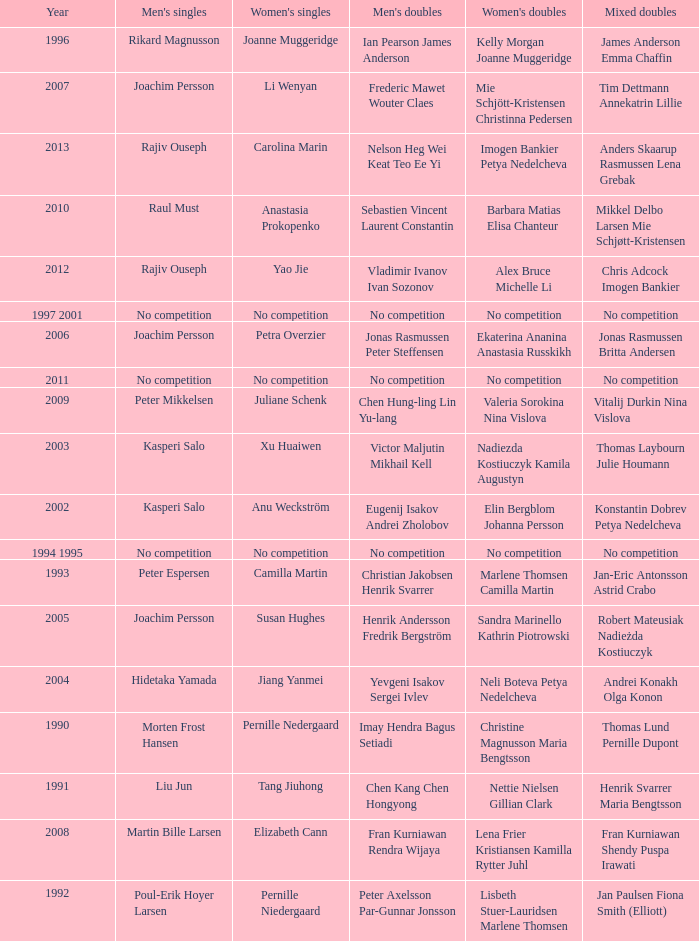Who won the Mixed doubles when Juliane Schenk won the Women's Singles? Vitalij Durkin Nina Vislova. 